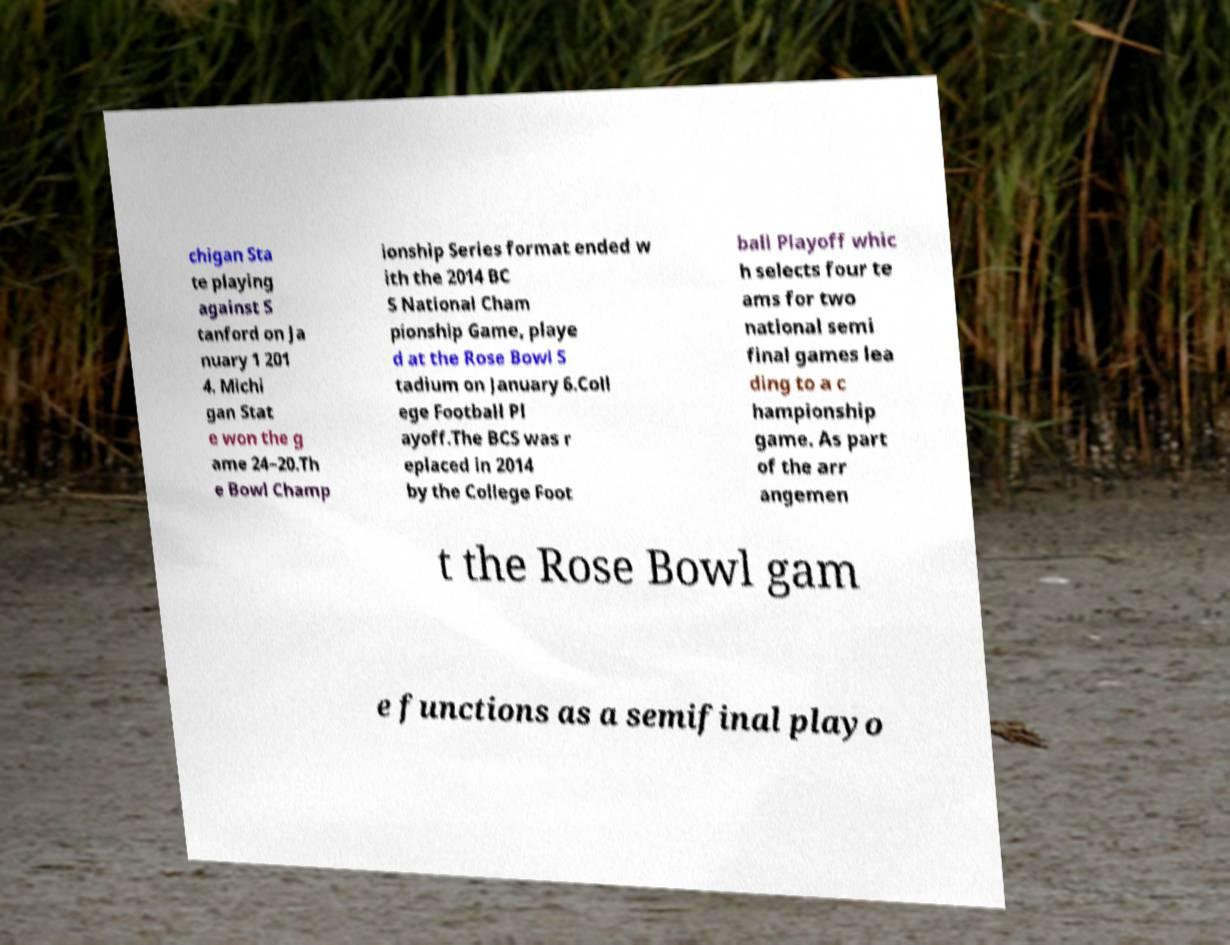Can you read and provide the text displayed in the image?This photo seems to have some interesting text. Can you extract and type it out for me? chigan Sta te playing against S tanford on Ja nuary 1 201 4. Michi gan Stat e won the g ame 24–20.Th e Bowl Champ ionship Series format ended w ith the 2014 BC S National Cham pionship Game, playe d at the Rose Bowl S tadium on January 6.Coll ege Football Pl ayoff.The BCS was r eplaced in 2014 by the College Foot ball Playoff whic h selects four te ams for two national semi final games lea ding to a c hampionship game. As part of the arr angemen t the Rose Bowl gam e functions as a semifinal playo 